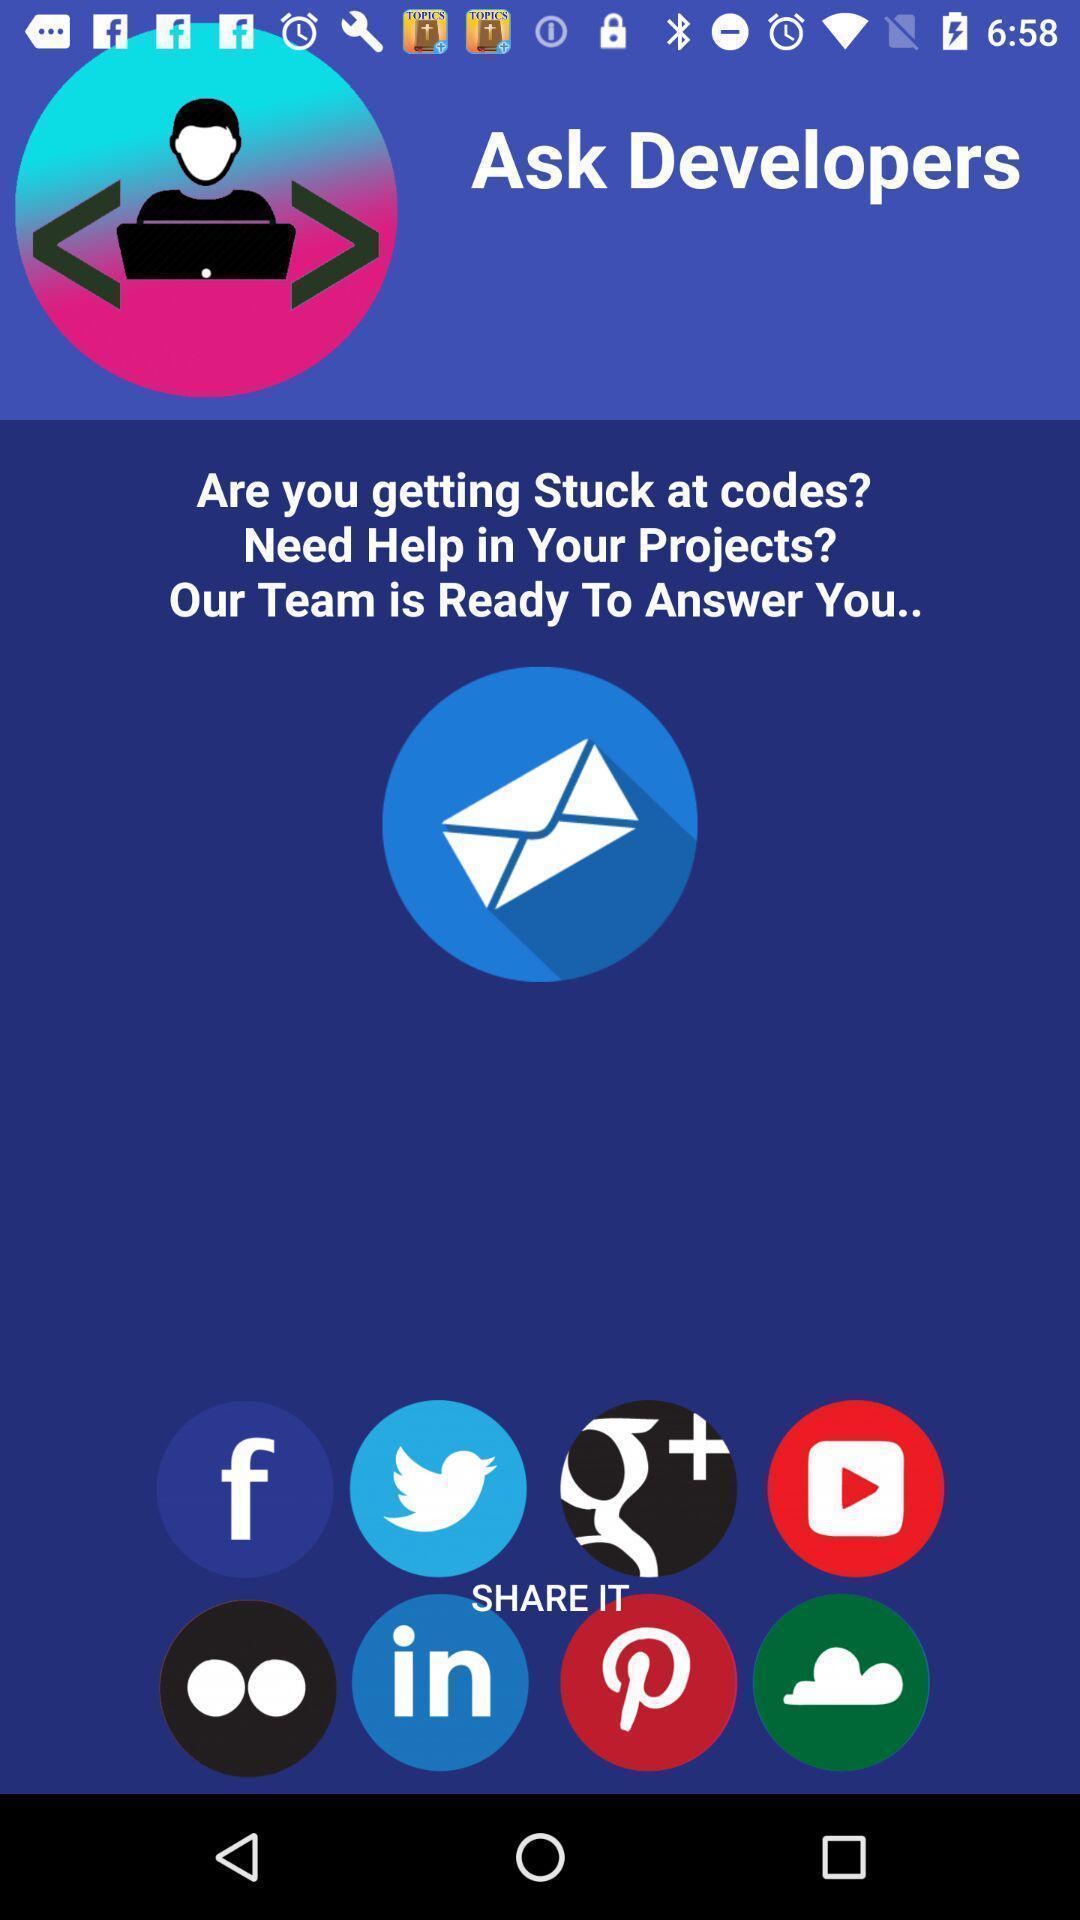Describe the content in this image. Welcome page of a social app. 